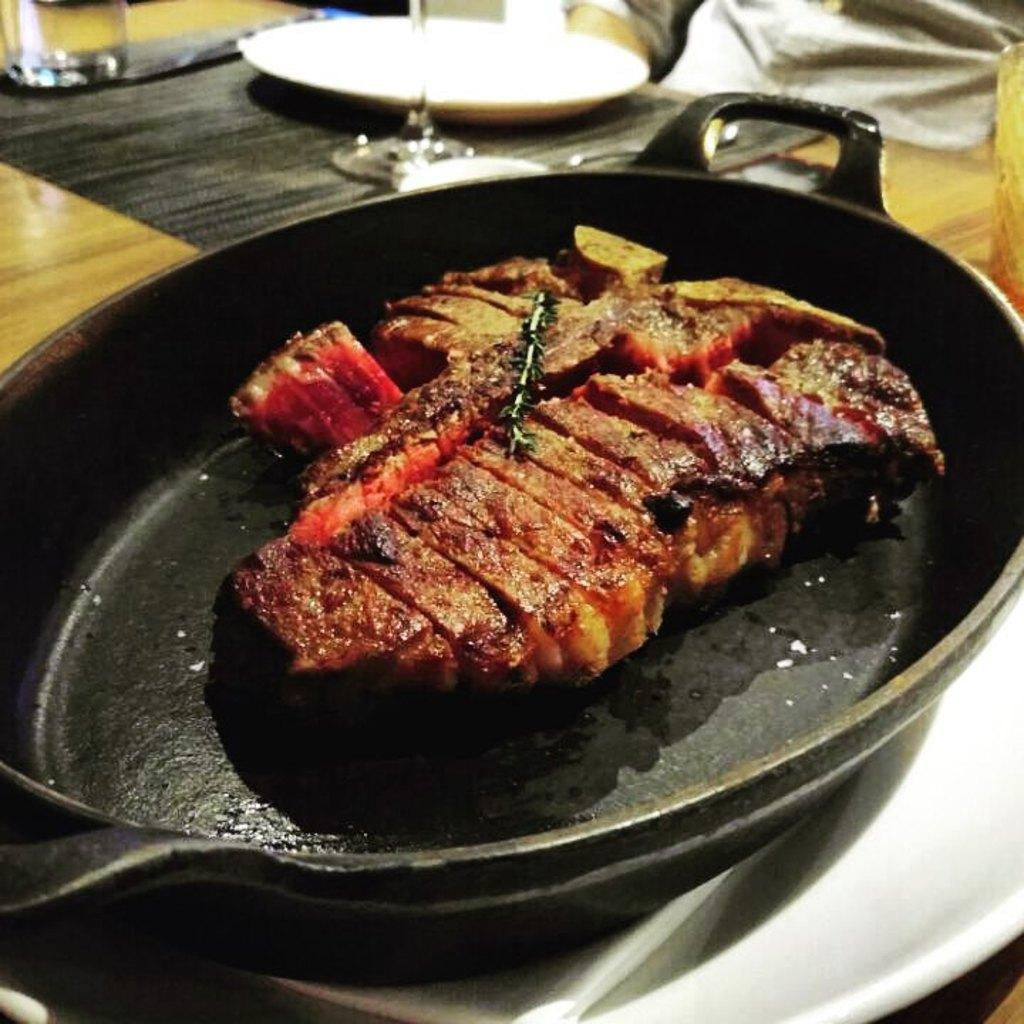What is in the pan that is visible in the image? There is food in a pan in the image. What is located beside the pan? There is a plate beside the pan. What can be seen on the table in the image? There are glasses on the table. Can you describe any other items on the table? There are other unspecified things on the table. Can you tell me how many visitors are visible in the image? There are no visitors present in the image. What type of lake can be seen in the background of the image? There is no lake visible in the image. 